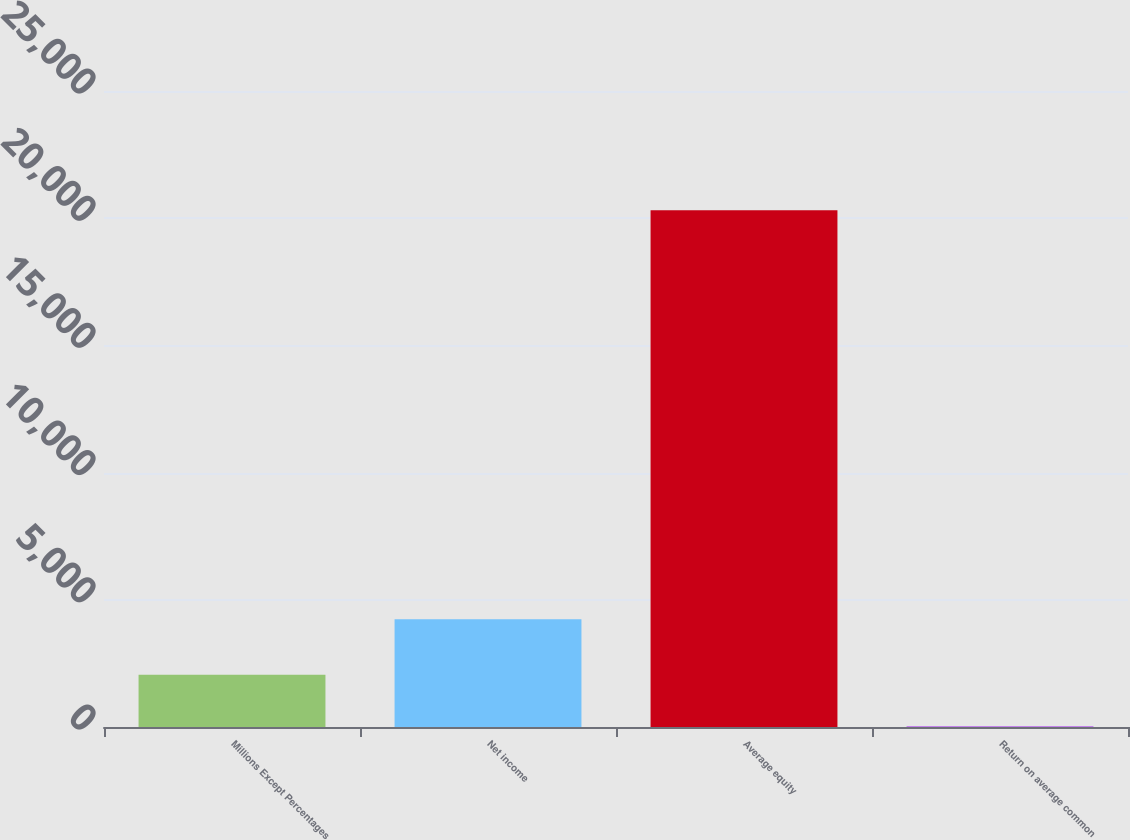Convert chart. <chart><loc_0><loc_0><loc_500><loc_500><bar_chart><fcel>Millions Except Percentages<fcel>Net income<fcel>Average equity<fcel>Return on average common<nl><fcel>2050.42<fcel>4233<fcel>20317<fcel>20.8<nl></chart> 